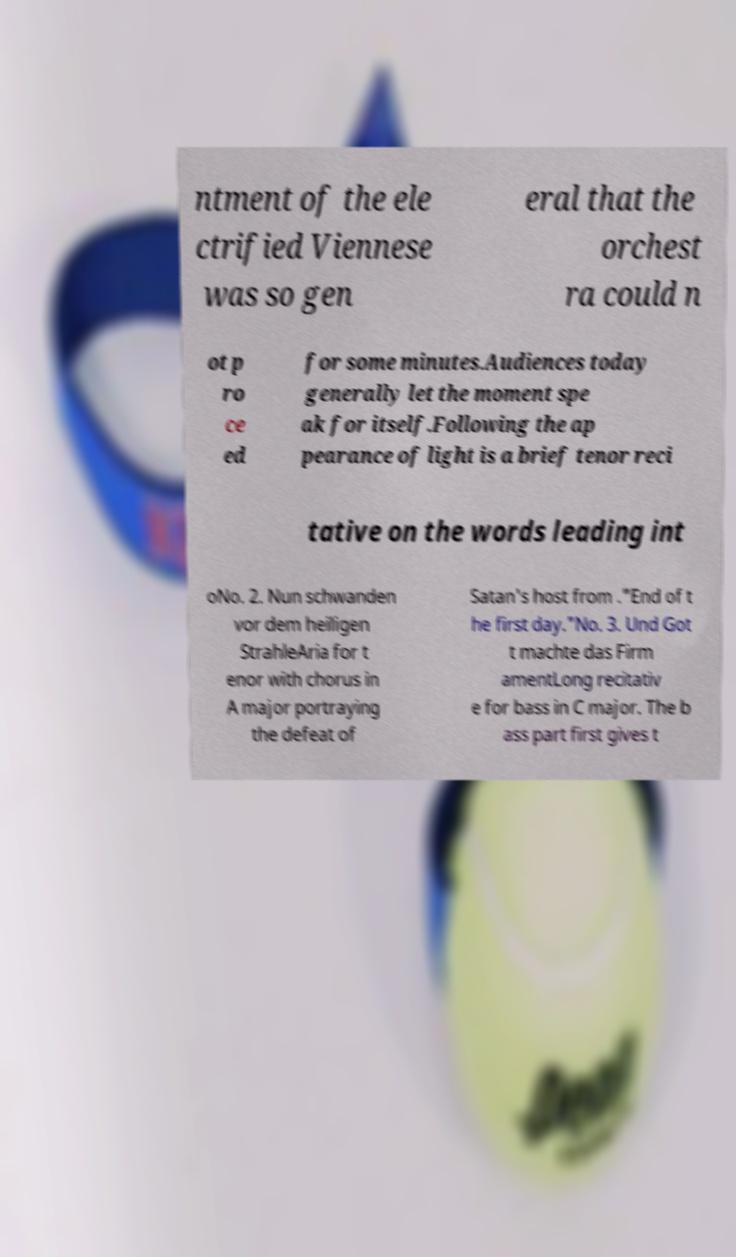What messages or text are displayed in this image? I need them in a readable, typed format. ntment of the ele ctrified Viennese was so gen eral that the orchest ra could n ot p ro ce ed for some minutes.Audiences today generally let the moment spe ak for itself.Following the ap pearance of light is a brief tenor reci tative on the words leading int oNo. 2. Nun schwanden vor dem heiligen StrahleAria for t enor with chorus in A major portraying the defeat of Satan's host from ."End of t he first day."No. 3. Und Got t machte das Firm amentLong recitativ e for bass in C major. The b ass part first gives t 